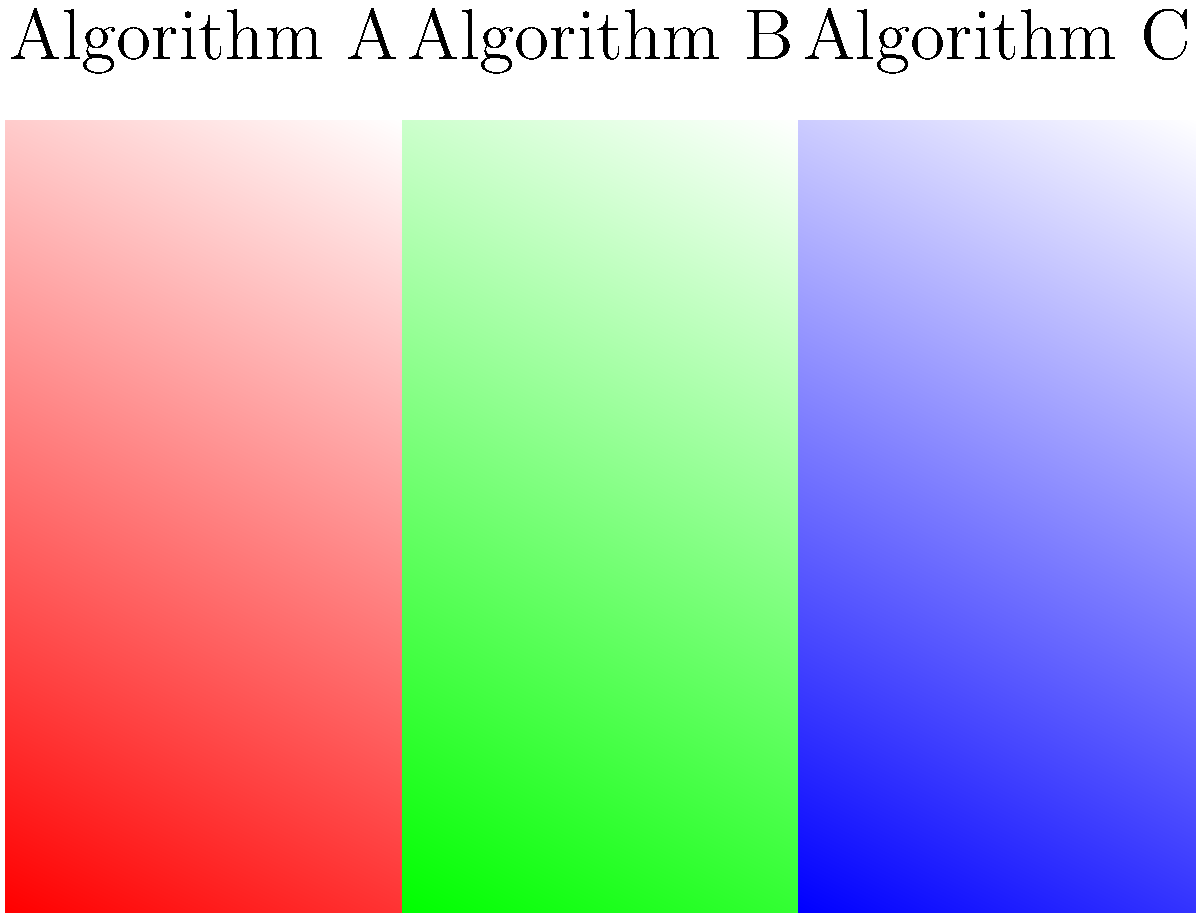Based on the color gradients generated by three different algorithms (A, B, and C) shown above, which algorithm is most likely to evoke a sense of calmness in viewers, and why? To answer this question, we need to consider the psychological effects of colors and their gradients:

1. Algorithm A (Red to White): 
   - Red is often associated with excitement, energy, and intensity.
   - The gradient to white softens the effect but still maintains a stimulating quality.

2. Algorithm B (Green to White):
   - Green is typically associated with nature, growth, and harmony.
   - The gradient to white creates a soothing, gentle transition.

3. Algorithm C (Blue to White):
   - Blue is generally associated with calmness, serenity, and stability.
   - The gradient to white enhances the peaceful quality of blue.

Comparing these:
- Red (A) is the most stimulating and least calming.
- Green (B) is calming but not as serene as blue.
- Blue (C) is most commonly associated with calmness and tranquility.

Therefore, Algorithm C (Blue to White) is most likely to evoke a sense of calmness in viewers due to the psychological associations of blue with serenity and the gentle gradient to white, which further softens the effect.
Answer: Algorithm C (Blue to White) 